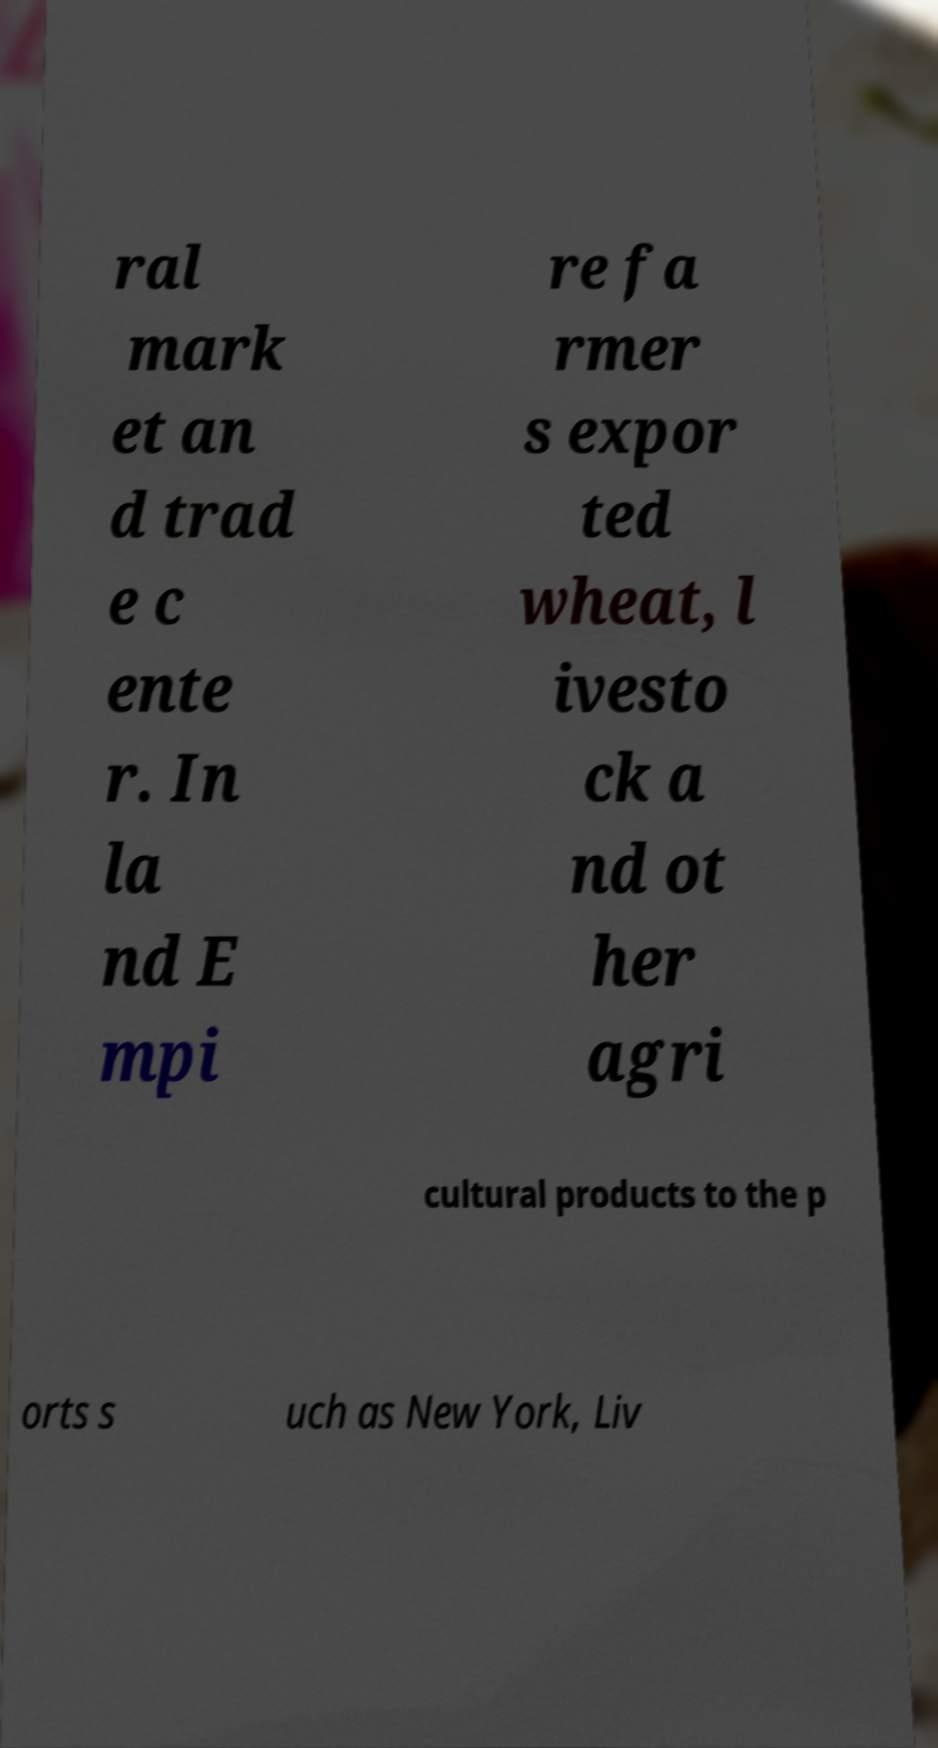I need the written content from this picture converted into text. Can you do that? ral mark et an d trad e c ente r. In la nd E mpi re fa rmer s expor ted wheat, l ivesto ck a nd ot her agri cultural products to the p orts s uch as New York, Liv 